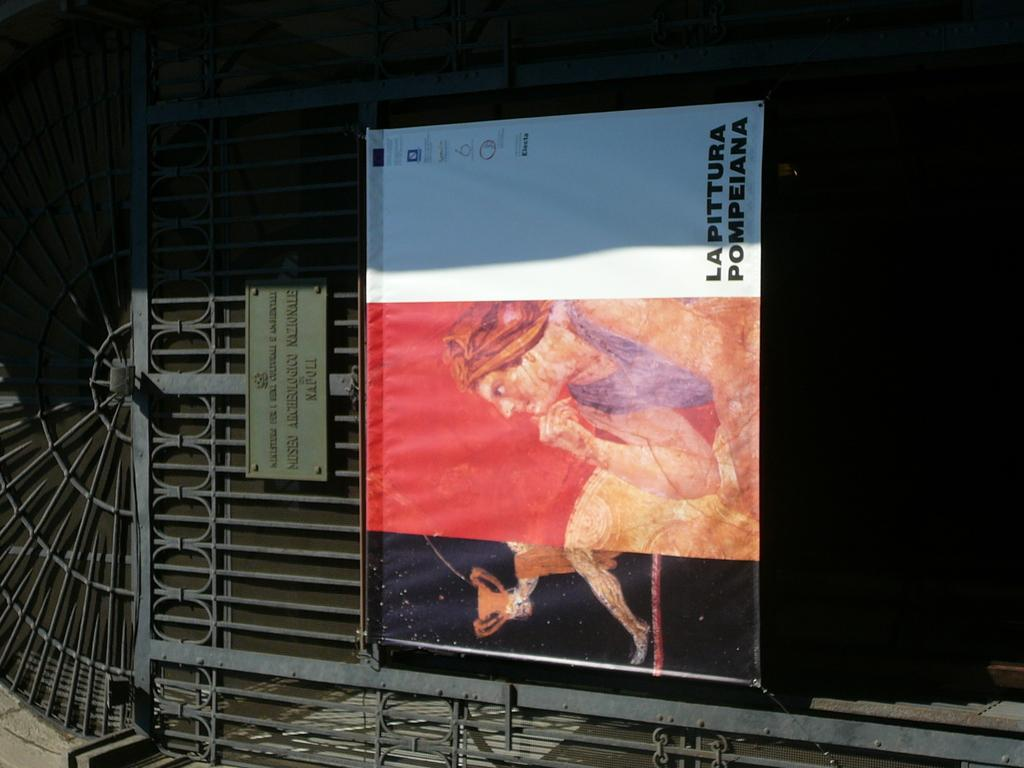<image>
Provide a brief description of the given image. A sign has vertical text reading Lapittura Pompeiana. 